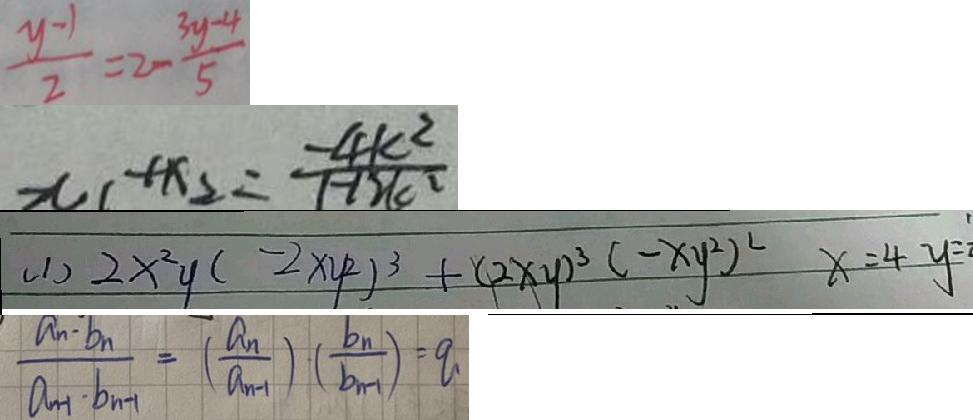<formula> <loc_0><loc_0><loc_500><loc_500>\frac { y - 1 } { 2 } = 2 - \frac { 3 y - 4 } { 5 } 
 x _ { 1 } + x _ { 2 } = \frac { - 4 k ^ { 2 } } { 1 - 1 2 k ^ { 2 } } 
 ( 1 ) 2 x ^ { 2 } y ( - 2 x y ^ { 2 } ) ^ { 3 } + ( 2 x y ) ^ { 3 } ( - x y ^ { 2 } ) ^ { 2 } x = 4 y = 
 \frac { a _ { n } \cdot b _ { n } } { a _ { n + 1 } \cdot b _ { n } } = ( \frac { a _ { n } } { a _ { n - 1 } } ) \cdot ( \frac { b _ { n } } { a _ { n + 1 } } ) = q</formula> 